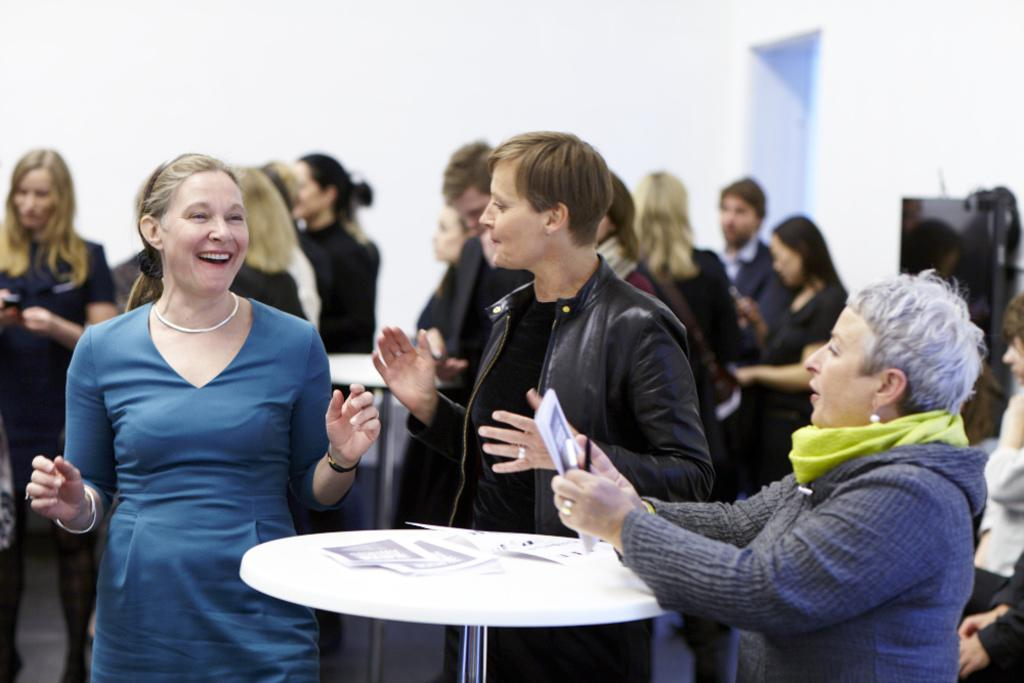How many women are in the image? There are three women in the image. What are the women doing in the image? The women are standing at a table and talking. What is on the table with the women? There are papers on the table. Can you describe the surrounding environment in the image? There are other people at tables behind the three women. What type of hen can be seen interacting with the women in the image? There is no hen present in the image; it features three women standing at a table and talking. What type of trade is being conducted by the women in the image? There is no indication of any trade being conducted in the image; the women are simply talking at a table. 